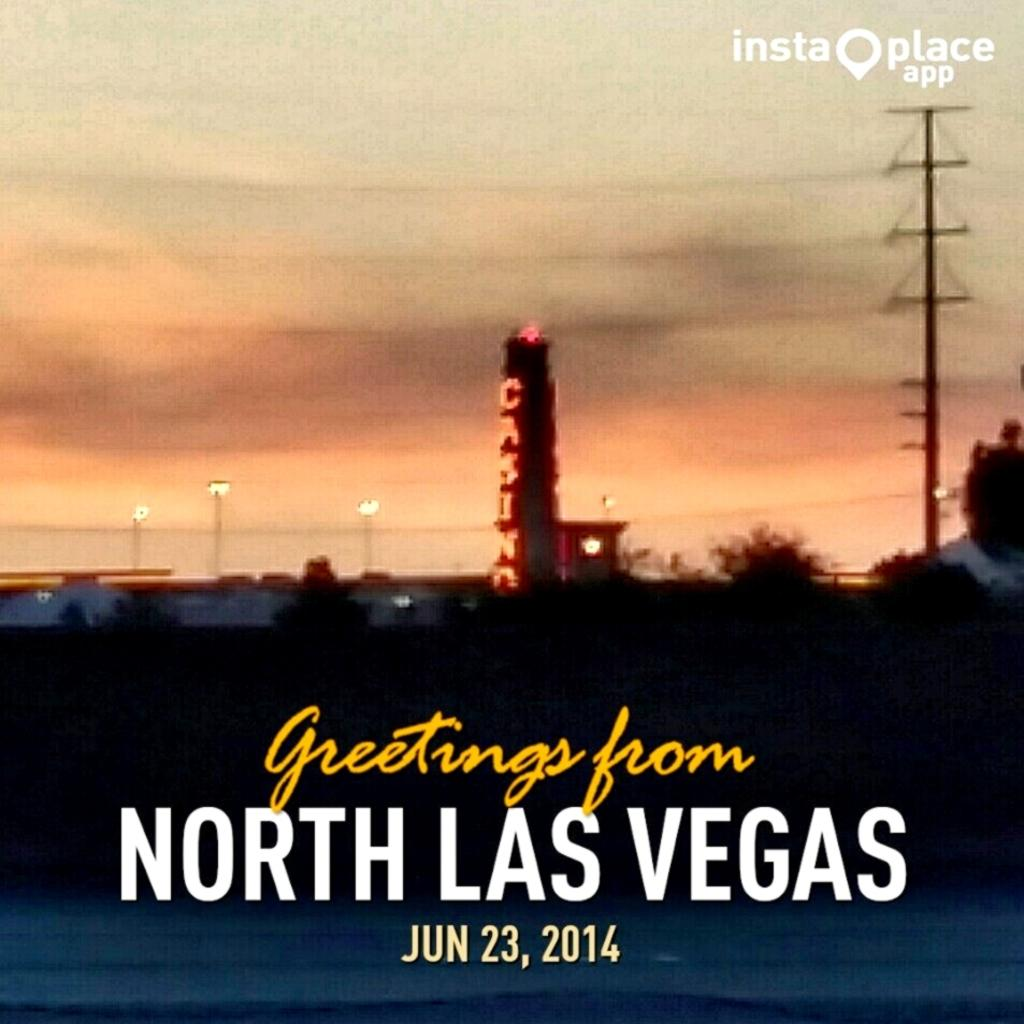Provide a one-sentence caption for the provided image. a photo of a casino from north las vegas in 2014. 